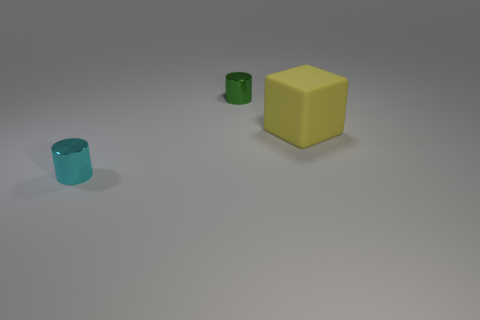How many large gray shiny spheres are there?
Make the answer very short. 0. The big rubber block behind the small metallic cylinder on the left side of the small green thing is what color?
Offer a terse response. Yellow. There is a cylinder that is the same size as the cyan thing; what color is it?
Offer a terse response. Green. Is there a small cylinder that has the same color as the big thing?
Keep it short and to the point. No. Are there any cylinders?
Give a very brief answer. Yes. There is a tiny object that is to the left of the green cylinder; what shape is it?
Give a very brief answer. Cylinder. How many things are both on the left side of the large rubber cube and behind the cyan metallic object?
Ensure brevity in your answer.  1. How many other things are there of the same size as the matte thing?
Provide a succinct answer. 0. Do the small shiny thing behind the large yellow object and the object that is in front of the big matte object have the same shape?
Give a very brief answer. Yes. How many things are either small cyan cylinders or yellow matte cubes that are behind the tiny cyan shiny cylinder?
Your answer should be compact. 2. 